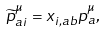Convert formula to latex. <formula><loc_0><loc_0><loc_500><loc_500>\widetilde { p } _ { a i } ^ { \mu } = x _ { i , a b } p _ { a } ^ { \mu } ,</formula> 